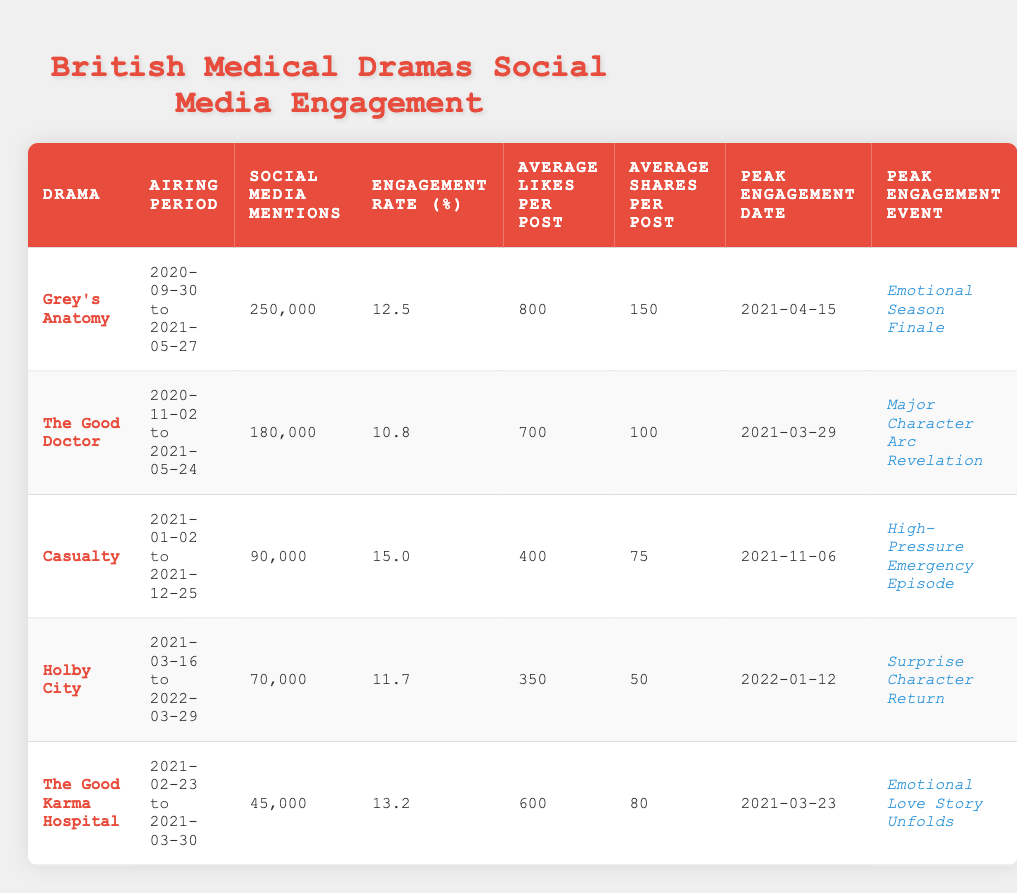What is the drama with the highest social media mentions? Referring to the table, "Grey's Anatomy" has 250,000 social media mentions, which is the highest compared to other dramas listed.
Answer: Grey's Anatomy Which drama has the highest engagement rate? Upon review, "Casualty" shows the highest engagement rate at 15.0%, surpassing the other dramas in the table.
Answer: Casualty What is the average likes per post for "The Good Doctor"? Looking at the data, "The Good Doctor" has an average of 700 likes per post.
Answer: 700 Which drama had its peak engagement date on March 29, 2021? The table indicates that "The Good Doctor" recorded its peak engagement on March 29, 2021.
Answer: The Good Doctor How many total social media mentions did all the dramas receive combined? Adding all the social media mentions: 250,000 + 180,000 + 90,000 + 70,000 + 45,000 = 635,000. Thus, the total is 635,000.
Answer: 635,000 Is it true that "Holby City" had a higher average shares per post than "The Good Karma Hospital"? Checking the table, "Holby City" has 50 average shares, while "The Good Karma Hospital" has 80 average shares. Therefore, this statement is false.
Answer: False What is the engagement rate difference between "Grey's Anatomy" and "Casualty"? The engagement rate for "Grey's Anatomy" is 12.5% and for "Casualty" it is 15.0%. The difference is calculated as 15.0% - 12.5% = 2.5%.
Answer: 2.5% Which drama had its peak engagement event described as the "Emotional Season Finale"? The peak engagement event as "Emotional Season Finale" is associated with "Grey's Anatomy" according to the table.
Answer: Grey's Anatomy What is the average number of shares per post for all dramas listed? To find the average shares: (150 + 100 + 75 + 50 + 80) / 5 = 91. The average number of shares per post across all dramas is 91.
Answer: 91 Did "The Good Karma Hospital" have more social media mentions than "Holby City"? The table shows "The Good Karma Hospital" has 45,000 mentions, while "Holby City" has 70,000, so this is false.
Answer: False 